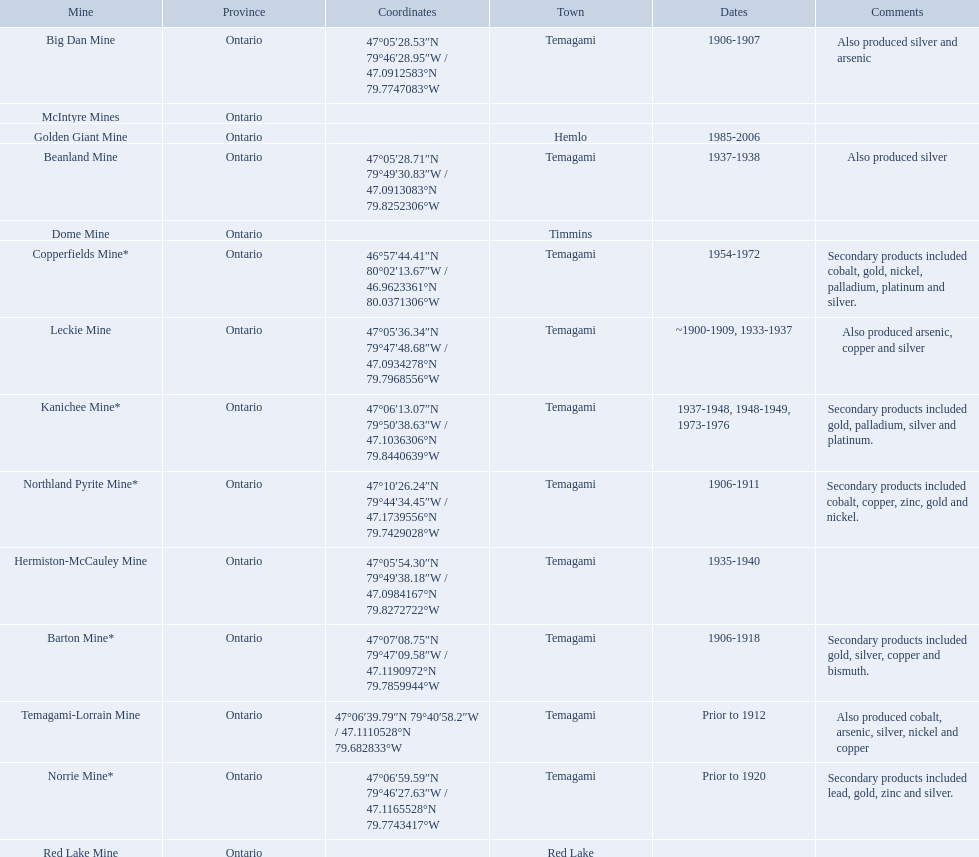What are all the mines with dates listed? Barton Mine*, Beanland Mine, Big Dan Mine, Copperfields Mine*, Golden Giant Mine, Hermiston-McCauley Mine, Kanichee Mine*, Leckie Mine, Norrie Mine*, Northland Pyrite Mine*, Temagami-Lorrain Mine. Which of those dates include the year that the mine was closed? 1906-1918, 1937-1938, 1906-1907, 1954-1972, 1985-2006, 1935-1940, 1937-1948, 1948-1949, 1973-1976, ~1900-1909, 1933-1937, 1906-1911. Which of those mines were opened the longest? Golden Giant Mine. 